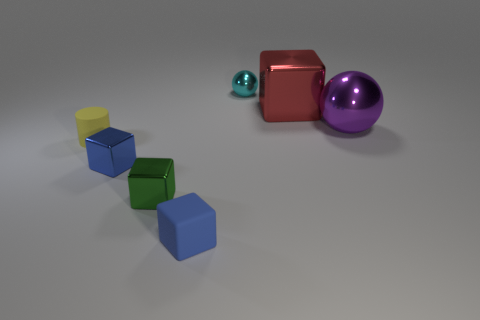What number of blue things are either tiny spheres or large shiny blocks?
Give a very brief answer. 0. How many other objects are the same shape as the tiny blue rubber thing?
Ensure brevity in your answer.  3. There is a tiny cube that is in front of the tiny green block; is its color the same as the tiny cube that is on the left side of the green shiny cube?
Keep it short and to the point. Yes. What number of big objects are either cylinders or purple blocks?
Ensure brevity in your answer.  0. There is a red object that is the same shape as the tiny blue rubber object; what size is it?
Provide a short and direct response. Large. There is a small blue block in front of the green metal block in front of the cylinder; what is its material?
Offer a terse response. Rubber. What number of shiny objects are small purple blocks or big objects?
Make the answer very short. 2. What is the color of the big object that is the same shape as the small cyan thing?
Keep it short and to the point. Purple. How many other tiny cylinders are the same color as the tiny cylinder?
Ensure brevity in your answer.  0. Are there any balls that are right of the blue thing in front of the green shiny thing?
Your answer should be very brief. Yes. 